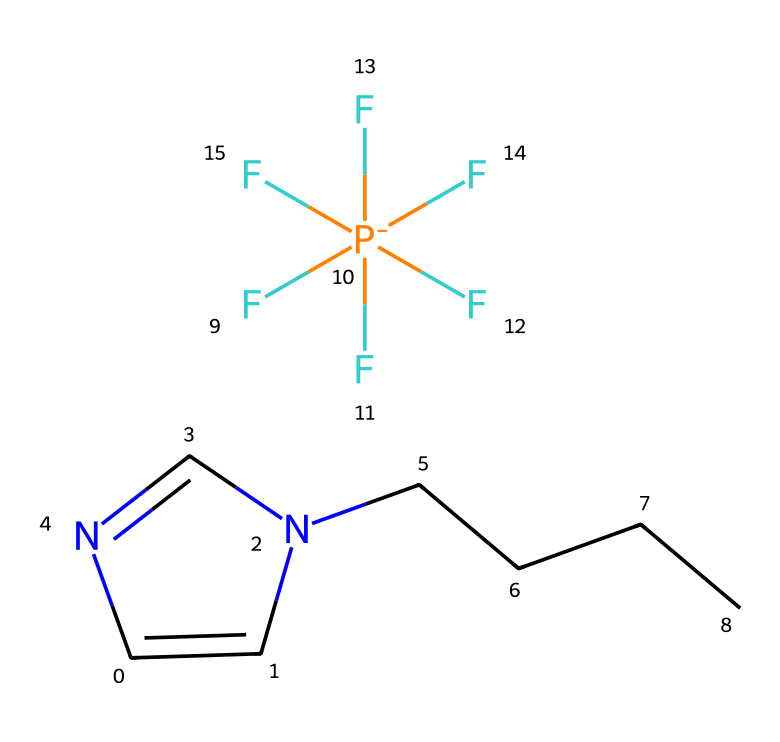What is the central atom in the cation of this ionic liquid? The central atom in the cation is nitrogen, identifiable by the position where it is part of the pyridine-like structure (C1=CN(C=N1)).
Answer: nitrogen How many fluorine atoms are in this ionic liquid? By analyzing the structure, there are five fluorine atoms connected to the phosphorous atom, indicated by the notation (F)(F)(F)(F)(F) in the SMILES.
Answer: five What type of bond is primarily present between the cation and anion in this ionic liquid? The bond between the cation and anion is primarily ionic, as is characteristic of ionic liquids, where there is an electrostatic attraction between the positively charged cation and the negatively charged anion.
Answer: ionic What is the function group that provides the liquid property in this compound? The function group that contributes to the ionic nature and thus liquid property is the ionic bonding between the cation and the anion derived from the fluorinated phosphorous species.
Answer: ionic bond What is the overall charge of this ionic liquid? The overall charge of the ionic liquid amounts to zero, balanced between the positively charged cation and the negatively charged anion (F[P-]).
Answer: zero 